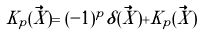Convert formula to latex. <formula><loc_0><loc_0><loc_500><loc_500>K _ { p } ( \vec { X } ) = ( - 1 ) ^ { p } \delta ( \vec { X } ) + \tilde { K } _ { p } ( \vec { X } )</formula> 